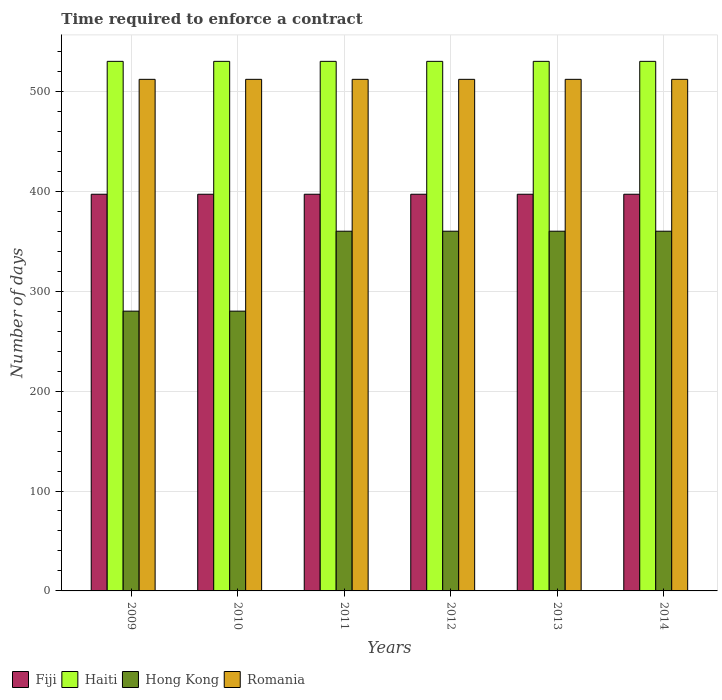How many different coloured bars are there?
Provide a succinct answer. 4. How many groups of bars are there?
Ensure brevity in your answer.  6. Are the number of bars on each tick of the X-axis equal?
Provide a short and direct response. Yes. In how many cases, is the number of bars for a given year not equal to the number of legend labels?
Provide a succinct answer. 0. What is the number of days required to enforce a contract in Haiti in 2011?
Offer a terse response. 530. Across all years, what is the maximum number of days required to enforce a contract in Haiti?
Ensure brevity in your answer.  530. Across all years, what is the minimum number of days required to enforce a contract in Haiti?
Offer a very short reply. 530. What is the total number of days required to enforce a contract in Romania in the graph?
Ensure brevity in your answer.  3072. What is the difference between the number of days required to enforce a contract in Fiji in 2011 and the number of days required to enforce a contract in Haiti in 2014?
Give a very brief answer. -133. What is the average number of days required to enforce a contract in Hong Kong per year?
Make the answer very short. 333.33. In the year 2011, what is the difference between the number of days required to enforce a contract in Hong Kong and number of days required to enforce a contract in Haiti?
Offer a very short reply. -170. In how many years, is the number of days required to enforce a contract in Haiti greater than 340 days?
Provide a succinct answer. 6. What is the ratio of the number of days required to enforce a contract in Haiti in 2010 to that in 2012?
Ensure brevity in your answer.  1. Is the number of days required to enforce a contract in Fiji in 2013 less than that in 2014?
Keep it short and to the point. No. What is the difference between the highest and the lowest number of days required to enforce a contract in Fiji?
Give a very brief answer. 0. Is the sum of the number of days required to enforce a contract in Fiji in 2010 and 2012 greater than the maximum number of days required to enforce a contract in Haiti across all years?
Make the answer very short. Yes. Is it the case that in every year, the sum of the number of days required to enforce a contract in Hong Kong and number of days required to enforce a contract in Haiti is greater than the sum of number of days required to enforce a contract in Romania and number of days required to enforce a contract in Fiji?
Provide a succinct answer. No. What does the 3rd bar from the left in 2012 represents?
Your answer should be compact. Hong Kong. What does the 3rd bar from the right in 2011 represents?
Your answer should be very brief. Haiti. How many years are there in the graph?
Offer a very short reply. 6. What is the difference between two consecutive major ticks on the Y-axis?
Offer a terse response. 100. Does the graph contain any zero values?
Your response must be concise. No. Does the graph contain grids?
Your response must be concise. Yes. Where does the legend appear in the graph?
Give a very brief answer. Bottom left. How many legend labels are there?
Provide a short and direct response. 4. How are the legend labels stacked?
Ensure brevity in your answer.  Horizontal. What is the title of the graph?
Your response must be concise. Time required to enforce a contract. What is the label or title of the Y-axis?
Offer a very short reply. Number of days. What is the Number of days in Fiji in 2009?
Give a very brief answer. 397. What is the Number of days in Haiti in 2009?
Your answer should be compact. 530. What is the Number of days of Hong Kong in 2009?
Give a very brief answer. 280. What is the Number of days of Romania in 2009?
Ensure brevity in your answer.  512. What is the Number of days of Fiji in 2010?
Give a very brief answer. 397. What is the Number of days in Haiti in 2010?
Your answer should be very brief. 530. What is the Number of days in Hong Kong in 2010?
Offer a very short reply. 280. What is the Number of days of Romania in 2010?
Offer a very short reply. 512. What is the Number of days of Fiji in 2011?
Provide a succinct answer. 397. What is the Number of days of Haiti in 2011?
Your answer should be very brief. 530. What is the Number of days of Hong Kong in 2011?
Provide a succinct answer. 360. What is the Number of days in Romania in 2011?
Keep it short and to the point. 512. What is the Number of days in Fiji in 2012?
Provide a short and direct response. 397. What is the Number of days of Haiti in 2012?
Provide a short and direct response. 530. What is the Number of days in Hong Kong in 2012?
Ensure brevity in your answer.  360. What is the Number of days in Romania in 2012?
Keep it short and to the point. 512. What is the Number of days of Fiji in 2013?
Your response must be concise. 397. What is the Number of days in Haiti in 2013?
Your answer should be compact. 530. What is the Number of days in Hong Kong in 2013?
Keep it short and to the point. 360. What is the Number of days in Romania in 2013?
Make the answer very short. 512. What is the Number of days of Fiji in 2014?
Keep it short and to the point. 397. What is the Number of days of Haiti in 2014?
Provide a succinct answer. 530. What is the Number of days in Hong Kong in 2014?
Your answer should be very brief. 360. What is the Number of days of Romania in 2014?
Your response must be concise. 512. Across all years, what is the maximum Number of days of Fiji?
Offer a very short reply. 397. Across all years, what is the maximum Number of days of Haiti?
Ensure brevity in your answer.  530. Across all years, what is the maximum Number of days of Hong Kong?
Your response must be concise. 360. Across all years, what is the maximum Number of days in Romania?
Give a very brief answer. 512. Across all years, what is the minimum Number of days in Fiji?
Provide a succinct answer. 397. Across all years, what is the minimum Number of days in Haiti?
Ensure brevity in your answer.  530. Across all years, what is the minimum Number of days in Hong Kong?
Provide a short and direct response. 280. Across all years, what is the minimum Number of days of Romania?
Give a very brief answer. 512. What is the total Number of days of Fiji in the graph?
Your answer should be compact. 2382. What is the total Number of days in Haiti in the graph?
Your answer should be very brief. 3180. What is the total Number of days of Hong Kong in the graph?
Ensure brevity in your answer.  2000. What is the total Number of days of Romania in the graph?
Provide a short and direct response. 3072. What is the difference between the Number of days in Fiji in 2009 and that in 2010?
Give a very brief answer. 0. What is the difference between the Number of days of Haiti in 2009 and that in 2010?
Offer a very short reply. 0. What is the difference between the Number of days in Hong Kong in 2009 and that in 2010?
Provide a short and direct response. 0. What is the difference between the Number of days in Fiji in 2009 and that in 2011?
Your answer should be very brief. 0. What is the difference between the Number of days in Haiti in 2009 and that in 2011?
Offer a very short reply. 0. What is the difference between the Number of days in Hong Kong in 2009 and that in 2011?
Your answer should be compact. -80. What is the difference between the Number of days in Romania in 2009 and that in 2011?
Your response must be concise. 0. What is the difference between the Number of days in Hong Kong in 2009 and that in 2012?
Your answer should be very brief. -80. What is the difference between the Number of days in Romania in 2009 and that in 2012?
Provide a succinct answer. 0. What is the difference between the Number of days in Fiji in 2009 and that in 2013?
Offer a very short reply. 0. What is the difference between the Number of days in Hong Kong in 2009 and that in 2013?
Provide a short and direct response. -80. What is the difference between the Number of days of Romania in 2009 and that in 2013?
Give a very brief answer. 0. What is the difference between the Number of days in Hong Kong in 2009 and that in 2014?
Ensure brevity in your answer.  -80. What is the difference between the Number of days of Haiti in 2010 and that in 2011?
Offer a very short reply. 0. What is the difference between the Number of days of Hong Kong in 2010 and that in 2011?
Your answer should be very brief. -80. What is the difference between the Number of days of Fiji in 2010 and that in 2012?
Your answer should be compact. 0. What is the difference between the Number of days of Hong Kong in 2010 and that in 2012?
Ensure brevity in your answer.  -80. What is the difference between the Number of days in Fiji in 2010 and that in 2013?
Your answer should be compact. 0. What is the difference between the Number of days of Haiti in 2010 and that in 2013?
Provide a short and direct response. 0. What is the difference between the Number of days of Hong Kong in 2010 and that in 2013?
Make the answer very short. -80. What is the difference between the Number of days in Romania in 2010 and that in 2013?
Your answer should be very brief. 0. What is the difference between the Number of days of Hong Kong in 2010 and that in 2014?
Make the answer very short. -80. What is the difference between the Number of days of Fiji in 2011 and that in 2012?
Provide a succinct answer. 0. What is the difference between the Number of days of Haiti in 2011 and that in 2013?
Make the answer very short. 0. What is the difference between the Number of days of Hong Kong in 2011 and that in 2013?
Your answer should be compact. 0. What is the difference between the Number of days of Romania in 2011 and that in 2013?
Your answer should be compact. 0. What is the difference between the Number of days of Fiji in 2011 and that in 2014?
Offer a terse response. 0. What is the difference between the Number of days in Haiti in 2011 and that in 2014?
Provide a succinct answer. 0. What is the difference between the Number of days in Fiji in 2012 and that in 2013?
Provide a succinct answer. 0. What is the difference between the Number of days of Hong Kong in 2012 and that in 2013?
Make the answer very short. 0. What is the difference between the Number of days of Romania in 2012 and that in 2013?
Provide a succinct answer. 0. What is the difference between the Number of days in Fiji in 2012 and that in 2014?
Your answer should be very brief. 0. What is the difference between the Number of days of Romania in 2012 and that in 2014?
Make the answer very short. 0. What is the difference between the Number of days in Haiti in 2013 and that in 2014?
Provide a short and direct response. 0. What is the difference between the Number of days in Fiji in 2009 and the Number of days in Haiti in 2010?
Your answer should be very brief. -133. What is the difference between the Number of days in Fiji in 2009 and the Number of days in Hong Kong in 2010?
Offer a very short reply. 117. What is the difference between the Number of days of Fiji in 2009 and the Number of days of Romania in 2010?
Your response must be concise. -115. What is the difference between the Number of days of Haiti in 2009 and the Number of days of Hong Kong in 2010?
Give a very brief answer. 250. What is the difference between the Number of days of Haiti in 2009 and the Number of days of Romania in 2010?
Offer a terse response. 18. What is the difference between the Number of days of Hong Kong in 2009 and the Number of days of Romania in 2010?
Keep it short and to the point. -232. What is the difference between the Number of days of Fiji in 2009 and the Number of days of Haiti in 2011?
Offer a very short reply. -133. What is the difference between the Number of days in Fiji in 2009 and the Number of days in Hong Kong in 2011?
Ensure brevity in your answer.  37. What is the difference between the Number of days in Fiji in 2009 and the Number of days in Romania in 2011?
Offer a terse response. -115. What is the difference between the Number of days of Haiti in 2009 and the Number of days of Hong Kong in 2011?
Make the answer very short. 170. What is the difference between the Number of days of Hong Kong in 2009 and the Number of days of Romania in 2011?
Offer a terse response. -232. What is the difference between the Number of days in Fiji in 2009 and the Number of days in Haiti in 2012?
Your answer should be compact. -133. What is the difference between the Number of days in Fiji in 2009 and the Number of days in Hong Kong in 2012?
Your answer should be compact. 37. What is the difference between the Number of days in Fiji in 2009 and the Number of days in Romania in 2012?
Offer a terse response. -115. What is the difference between the Number of days in Haiti in 2009 and the Number of days in Hong Kong in 2012?
Offer a terse response. 170. What is the difference between the Number of days in Haiti in 2009 and the Number of days in Romania in 2012?
Offer a very short reply. 18. What is the difference between the Number of days of Hong Kong in 2009 and the Number of days of Romania in 2012?
Offer a terse response. -232. What is the difference between the Number of days of Fiji in 2009 and the Number of days of Haiti in 2013?
Provide a short and direct response. -133. What is the difference between the Number of days of Fiji in 2009 and the Number of days of Hong Kong in 2013?
Offer a very short reply. 37. What is the difference between the Number of days in Fiji in 2009 and the Number of days in Romania in 2013?
Provide a short and direct response. -115. What is the difference between the Number of days of Haiti in 2009 and the Number of days of Hong Kong in 2013?
Offer a terse response. 170. What is the difference between the Number of days of Haiti in 2009 and the Number of days of Romania in 2013?
Offer a terse response. 18. What is the difference between the Number of days of Hong Kong in 2009 and the Number of days of Romania in 2013?
Your response must be concise. -232. What is the difference between the Number of days in Fiji in 2009 and the Number of days in Haiti in 2014?
Your answer should be very brief. -133. What is the difference between the Number of days of Fiji in 2009 and the Number of days of Hong Kong in 2014?
Offer a terse response. 37. What is the difference between the Number of days of Fiji in 2009 and the Number of days of Romania in 2014?
Provide a short and direct response. -115. What is the difference between the Number of days in Haiti in 2009 and the Number of days in Hong Kong in 2014?
Offer a very short reply. 170. What is the difference between the Number of days of Hong Kong in 2009 and the Number of days of Romania in 2014?
Ensure brevity in your answer.  -232. What is the difference between the Number of days in Fiji in 2010 and the Number of days in Haiti in 2011?
Your answer should be compact. -133. What is the difference between the Number of days of Fiji in 2010 and the Number of days of Hong Kong in 2011?
Keep it short and to the point. 37. What is the difference between the Number of days of Fiji in 2010 and the Number of days of Romania in 2011?
Make the answer very short. -115. What is the difference between the Number of days in Haiti in 2010 and the Number of days in Hong Kong in 2011?
Your response must be concise. 170. What is the difference between the Number of days in Haiti in 2010 and the Number of days in Romania in 2011?
Give a very brief answer. 18. What is the difference between the Number of days of Hong Kong in 2010 and the Number of days of Romania in 2011?
Offer a terse response. -232. What is the difference between the Number of days of Fiji in 2010 and the Number of days of Haiti in 2012?
Ensure brevity in your answer.  -133. What is the difference between the Number of days in Fiji in 2010 and the Number of days in Romania in 2012?
Provide a succinct answer. -115. What is the difference between the Number of days in Haiti in 2010 and the Number of days in Hong Kong in 2012?
Keep it short and to the point. 170. What is the difference between the Number of days in Haiti in 2010 and the Number of days in Romania in 2012?
Your answer should be compact. 18. What is the difference between the Number of days of Hong Kong in 2010 and the Number of days of Romania in 2012?
Ensure brevity in your answer.  -232. What is the difference between the Number of days in Fiji in 2010 and the Number of days in Haiti in 2013?
Offer a terse response. -133. What is the difference between the Number of days of Fiji in 2010 and the Number of days of Romania in 2013?
Your response must be concise. -115. What is the difference between the Number of days in Haiti in 2010 and the Number of days in Hong Kong in 2013?
Provide a succinct answer. 170. What is the difference between the Number of days of Haiti in 2010 and the Number of days of Romania in 2013?
Provide a succinct answer. 18. What is the difference between the Number of days of Hong Kong in 2010 and the Number of days of Romania in 2013?
Ensure brevity in your answer.  -232. What is the difference between the Number of days in Fiji in 2010 and the Number of days in Haiti in 2014?
Ensure brevity in your answer.  -133. What is the difference between the Number of days in Fiji in 2010 and the Number of days in Hong Kong in 2014?
Ensure brevity in your answer.  37. What is the difference between the Number of days in Fiji in 2010 and the Number of days in Romania in 2014?
Give a very brief answer. -115. What is the difference between the Number of days of Haiti in 2010 and the Number of days of Hong Kong in 2014?
Give a very brief answer. 170. What is the difference between the Number of days in Haiti in 2010 and the Number of days in Romania in 2014?
Your answer should be compact. 18. What is the difference between the Number of days of Hong Kong in 2010 and the Number of days of Romania in 2014?
Your response must be concise. -232. What is the difference between the Number of days of Fiji in 2011 and the Number of days of Haiti in 2012?
Give a very brief answer. -133. What is the difference between the Number of days in Fiji in 2011 and the Number of days in Hong Kong in 2012?
Ensure brevity in your answer.  37. What is the difference between the Number of days of Fiji in 2011 and the Number of days of Romania in 2012?
Offer a terse response. -115. What is the difference between the Number of days of Haiti in 2011 and the Number of days of Hong Kong in 2012?
Keep it short and to the point. 170. What is the difference between the Number of days in Hong Kong in 2011 and the Number of days in Romania in 2012?
Ensure brevity in your answer.  -152. What is the difference between the Number of days in Fiji in 2011 and the Number of days in Haiti in 2013?
Your answer should be very brief. -133. What is the difference between the Number of days in Fiji in 2011 and the Number of days in Hong Kong in 2013?
Keep it short and to the point. 37. What is the difference between the Number of days in Fiji in 2011 and the Number of days in Romania in 2013?
Make the answer very short. -115. What is the difference between the Number of days of Haiti in 2011 and the Number of days of Hong Kong in 2013?
Your answer should be very brief. 170. What is the difference between the Number of days of Haiti in 2011 and the Number of days of Romania in 2013?
Give a very brief answer. 18. What is the difference between the Number of days of Hong Kong in 2011 and the Number of days of Romania in 2013?
Your response must be concise. -152. What is the difference between the Number of days in Fiji in 2011 and the Number of days in Haiti in 2014?
Provide a short and direct response. -133. What is the difference between the Number of days in Fiji in 2011 and the Number of days in Hong Kong in 2014?
Ensure brevity in your answer.  37. What is the difference between the Number of days in Fiji in 2011 and the Number of days in Romania in 2014?
Your response must be concise. -115. What is the difference between the Number of days of Haiti in 2011 and the Number of days of Hong Kong in 2014?
Your response must be concise. 170. What is the difference between the Number of days of Hong Kong in 2011 and the Number of days of Romania in 2014?
Provide a short and direct response. -152. What is the difference between the Number of days in Fiji in 2012 and the Number of days in Haiti in 2013?
Your answer should be compact. -133. What is the difference between the Number of days in Fiji in 2012 and the Number of days in Romania in 2013?
Keep it short and to the point. -115. What is the difference between the Number of days in Haiti in 2012 and the Number of days in Hong Kong in 2013?
Offer a terse response. 170. What is the difference between the Number of days in Haiti in 2012 and the Number of days in Romania in 2013?
Make the answer very short. 18. What is the difference between the Number of days of Hong Kong in 2012 and the Number of days of Romania in 2013?
Your answer should be compact. -152. What is the difference between the Number of days of Fiji in 2012 and the Number of days of Haiti in 2014?
Offer a terse response. -133. What is the difference between the Number of days in Fiji in 2012 and the Number of days in Romania in 2014?
Ensure brevity in your answer.  -115. What is the difference between the Number of days in Haiti in 2012 and the Number of days in Hong Kong in 2014?
Offer a terse response. 170. What is the difference between the Number of days in Haiti in 2012 and the Number of days in Romania in 2014?
Ensure brevity in your answer.  18. What is the difference between the Number of days of Hong Kong in 2012 and the Number of days of Romania in 2014?
Your answer should be compact. -152. What is the difference between the Number of days in Fiji in 2013 and the Number of days in Haiti in 2014?
Keep it short and to the point. -133. What is the difference between the Number of days of Fiji in 2013 and the Number of days of Romania in 2014?
Ensure brevity in your answer.  -115. What is the difference between the Number of days in Haiti in 2013 and the Number of days in Hong Kong in 2014?
Your answer should be very brief. 170. What is the difference between the Number of days in Hong Kong in 2013 and the Number of days in Romania in 2014?
Provide a short and direct response. -152. What is the average Number of days in Fiji per year?
Ensure brevity in your answer.  397. What is the average Number of days in Haiti per year?
Offer a terse response. 530. What is the average Number of days in Hong Kong per year?
Offer a terse response. 333.33. What is the average Number of days of Romania per year?
Offer a terse response. 512. In the year 2009, what is the difference between the Number of days in Fiji and Number of days in Haiti?
Offer a terse response. -133. In the year 2009, what is the difference between the Number of days of Fiji and Number of days of Hong Kong?
Offer a very short reply. 117. In the year 2009, what is the difference between the Number of days in Fiji and Number of days in Romania?
Keep it short and to the point. -115. In the year 2009, what is the difference between the Number of days in Haiti and Number of days in Hong Kong?
Offer a very short reply. 250. In the year 2009, what is the difference between the Number of days in Haiti and Number of days in Romania?
Make the answer very short. 18. In the year 2009, what is the difference between the Number of days in Hong Kong and Number of days in Romania?
Keep it short and to the point. -232. In the year 2010, what is the difference between the Number of days of Fiji and Number of days of Haiti?
Offer a very short reply. -133. In the year 2010, what is the difference between the Number of days of Fiji and Number of days of Hong Kong?
Provide a short and direct response. 117. In the year 2010, what is the difference between the Number of days of Fiji and Number of days of Romania?
Your answer should be very brief. -115. In the year 2010, what is the difference between the Number of days of Haiti and Number of days of Hong Kong?
Keep it short and to the point. 250. In the year 2010, what is the difference between the Number of days in Hong Kong and Number of days in Romania?
Give a very brief answer. -232. In the year 2011, what is the difference between the Number of days in Fiji and Number of days in Haiti?
Your answer should be very brief. -133. In the year 2011, what is the difference between the Number of days in Fiji and Number of days in Hong Kong?
Your response must be concise. 37. In the year 2011, what is the difference between the Number of days of Fiji and Number of days of Romania?
Keep it short and to the point. -115. In the year 2011, what is the difference between the Number of days of Haiti and Number of days of Hong Kong?
Make the answer very short. 170. In the year 2011, what is the difference between the Number of days of Hong Kong and Number of days of Romania?
Make the answer very short. -152. In the year 2012, what is the difference between the Number of days of Fiji and Number of days of Haiti?
Provide a short and direct response. -133. In the year 2012, what is the difference between the Number of days in Fiji and Number of days in Romania?
Offer a very short reply. -115. In the year 2012, what is the difference between the Number of days in Haiti and Number of days in Hong Kong?
Your answer should be compact. 170. In the year 2012, what is the difference between the Number of days in Haiti and Number of days in Romania?
Your response must be concise. 18. In the year 2012, what is the difference between the Number of days in Hong Kong and Number of days in Romania?
Ensure brevity in your answer.  -152. In the year 2013, what is the difference between the Number of days in Fiji and Number of days in Haiti?
Give a very brief answer. -133. In the year 2013, what is the difference between the Number of days of Fiji and Number of days of Hong Kong?
Your response must be concise. 37. In the year 2013, what is the difference between the Number of days in Fiji and Number of days in Romania?
Your answer should be compact. -115. In the year 2013, what is the difference between the Number of days in Haiti and Number of days in Hong Kong?
Your answer should be compact. 170. In the year 2013, what is the difference between the Number of days of Haiti and Number of days of Romania?
Keep it short and to the point. 18. In the year 2013, what is the difference between the Number of days in Hong Kong and Number of days in Romania?
Offer a terse response. -152. In the year 2014, what is the difference between the Number of days of Fiji and Number of days of Haiti?
Your answer should be very brief. -133. In the year 2014, what is the difference between the Number of days of Fiji and Number of days of Hong Kong?
Your response must be concise. 37. In the year 2014, what is the difference between the Number of days in Fiji and Number of days in Romania?
Offer a very short reply. -115. In the year 2014, what is the difference between the Number of days of Haiti and Number of days of Hong Kong?
Your response must be concise. 170. In the year 2014, what is the difference between the Number of days of Haiti and Number of days of Romania?
Provide a succinct answer. 18. In the year 2014, what is the difference between the Number of days of Hong Kong and Number of days of Romania?
Offer a terse response. -152. What is the ratio of the Number of days of Fiji in 2009 to that in 2010?
Offer a very short reply. 1. What is the ratio of the Number of days of Haiti in 2009 to that in 2011?
Offer a terse response. 1. What is the ratio of the Number of days of Romania in 2009 to that in 2011?
Your answer should be very brief. 1. What is the ratio of the Number of days of Haiti in 2009 to that in 2012?
Your answer should be very brief. 1. What is the ratio of the Number of days in Fiji in 2009 to that in 2013?
Ensure brevity in your answer.  1. What is the ratio of the Number of days in Haiti in 2009 to that in 2013?
Your answer should be very brief. 1. What is the ratio of the Number of days in Romania in 2009 to that in 2013?
Offer a terse response. 1. What is the ratio of the Number of days in Hong Kong in 2009 to that in 2014?
Your answer should be compact. 0.78. What is the ratio of the Number of days of Fiji in 2010 to that in 2011?
Give a very brief answer. 1. What is the ratio of the Number of days of Fiji in 2010 to that in 2012?
Give a very brief answer. 1. What is the ratio of the Number of days of Hong Kong in 2010 to that in 2012?
Offer a very short reply. 0.78. What is the ratio of the Number of days of Romania in 2010 to that in 2012?
Your answer should be compact. 1. What is the ratio of the Number of days in Haiti in 2010 to that in 2013?
Your response must be concise. 1. What is the ratio of the Number of days in Haiti in 2010 to that in 2014?
Give a very brief answer. 1. What is the ratio of the Number of days of Fiji in 2011 to that in 2013?
Provide a succinct answer. 1. What is the ratio of the Number of days in Haiti in 2011 to that in 2013?
Your answer should be very brief. 1. What is the ratio of the Number of days of Hong Kong in 2011 to that in 2014?
Offer a very short reply. 1. What is the ratio of the Number of days of Romania in 2011 to that in 2014?
Offer a terse response. 1. What is the ratio of the Number of days in Fiji in 2012 to that in 2013?
Your answer should be compact. 1. What is the ratio of the Number of days in Haiti in 2012 to that in 2013?
Keep it short and to the point. 1. What is the ratio of the Number of days in Hong Kong in 2012 to that in 2013?
Offer a terse response. 1. What is the ratio of the Number of days in Romania in 2012 to that in 2013?
Your response must be concise. 1. What is the ratio of the Number of days of Fiji in 2012 to that in 2014?
Keep it short and to the point. 1. What is the ratio of the Number of days of Haiti in 2012 to that in 2014?
Provide a short and direct response. 1. What is the ratio of the Number of days in Hong Kong in 2012 to that in 2014?
Provide a succinct answer. 1. What is the ratio of the Number of days in Romania in 2012 to that in 2014?
Give a very brief answer. 1. What is the ratio of the Number of days in Haiti in 2013 to that in 2014?
Keep it short and to the point. 1. What is the ratio of the Number of days in Romania in 2013 to that in 2014?
Your answer should be compact. 1. What is the difference between the highest and the second highest Number of days in Hong Kong?
Make the answer very short. 0. What is the difference between the highest and the second highest Number of days in Romania?
Make the answer very short. 0. What is the difference between the highest and the lowest Number of days of Haiti?
Give a very brief answer. 0. 